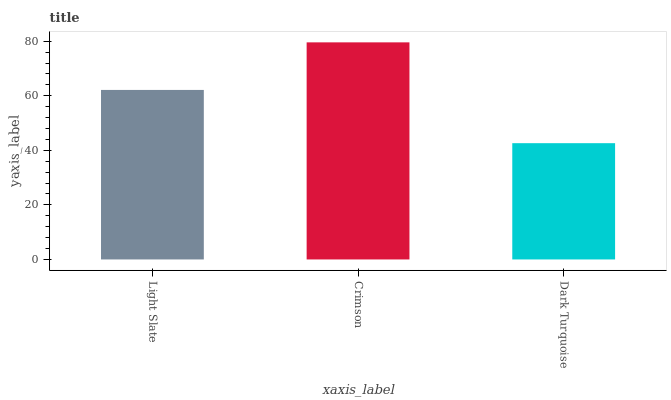Is Dark Turquoise the minimum?
Answer yes or no. Yes. Is Crimson the maximum?
Answer yes or no. Yes. Is Crimson the minimum?
Answer yes or no. No. Is Dark Turquoise the maximum?
Answer yes or no. No. Is Crimson greater than Dark Turquoise?
Answer yes or no. Yes. Is Dark Turquoise less than Crimson?
Answer yes or no. Yes. Is Dark Turquoise greater than Crimson?
Answer yes or no. No. Is Crimson less than Dark Turquoise?
Answer yes or no. No. Is Light Slate the high median?
Answer yes or no. Yes. Is Light Slate the low median?
Answer yes or no. Yes. Is Crimson the high median?
Answer yes or no. No. Is Crimson the low median?
Answer yes or no. No. 